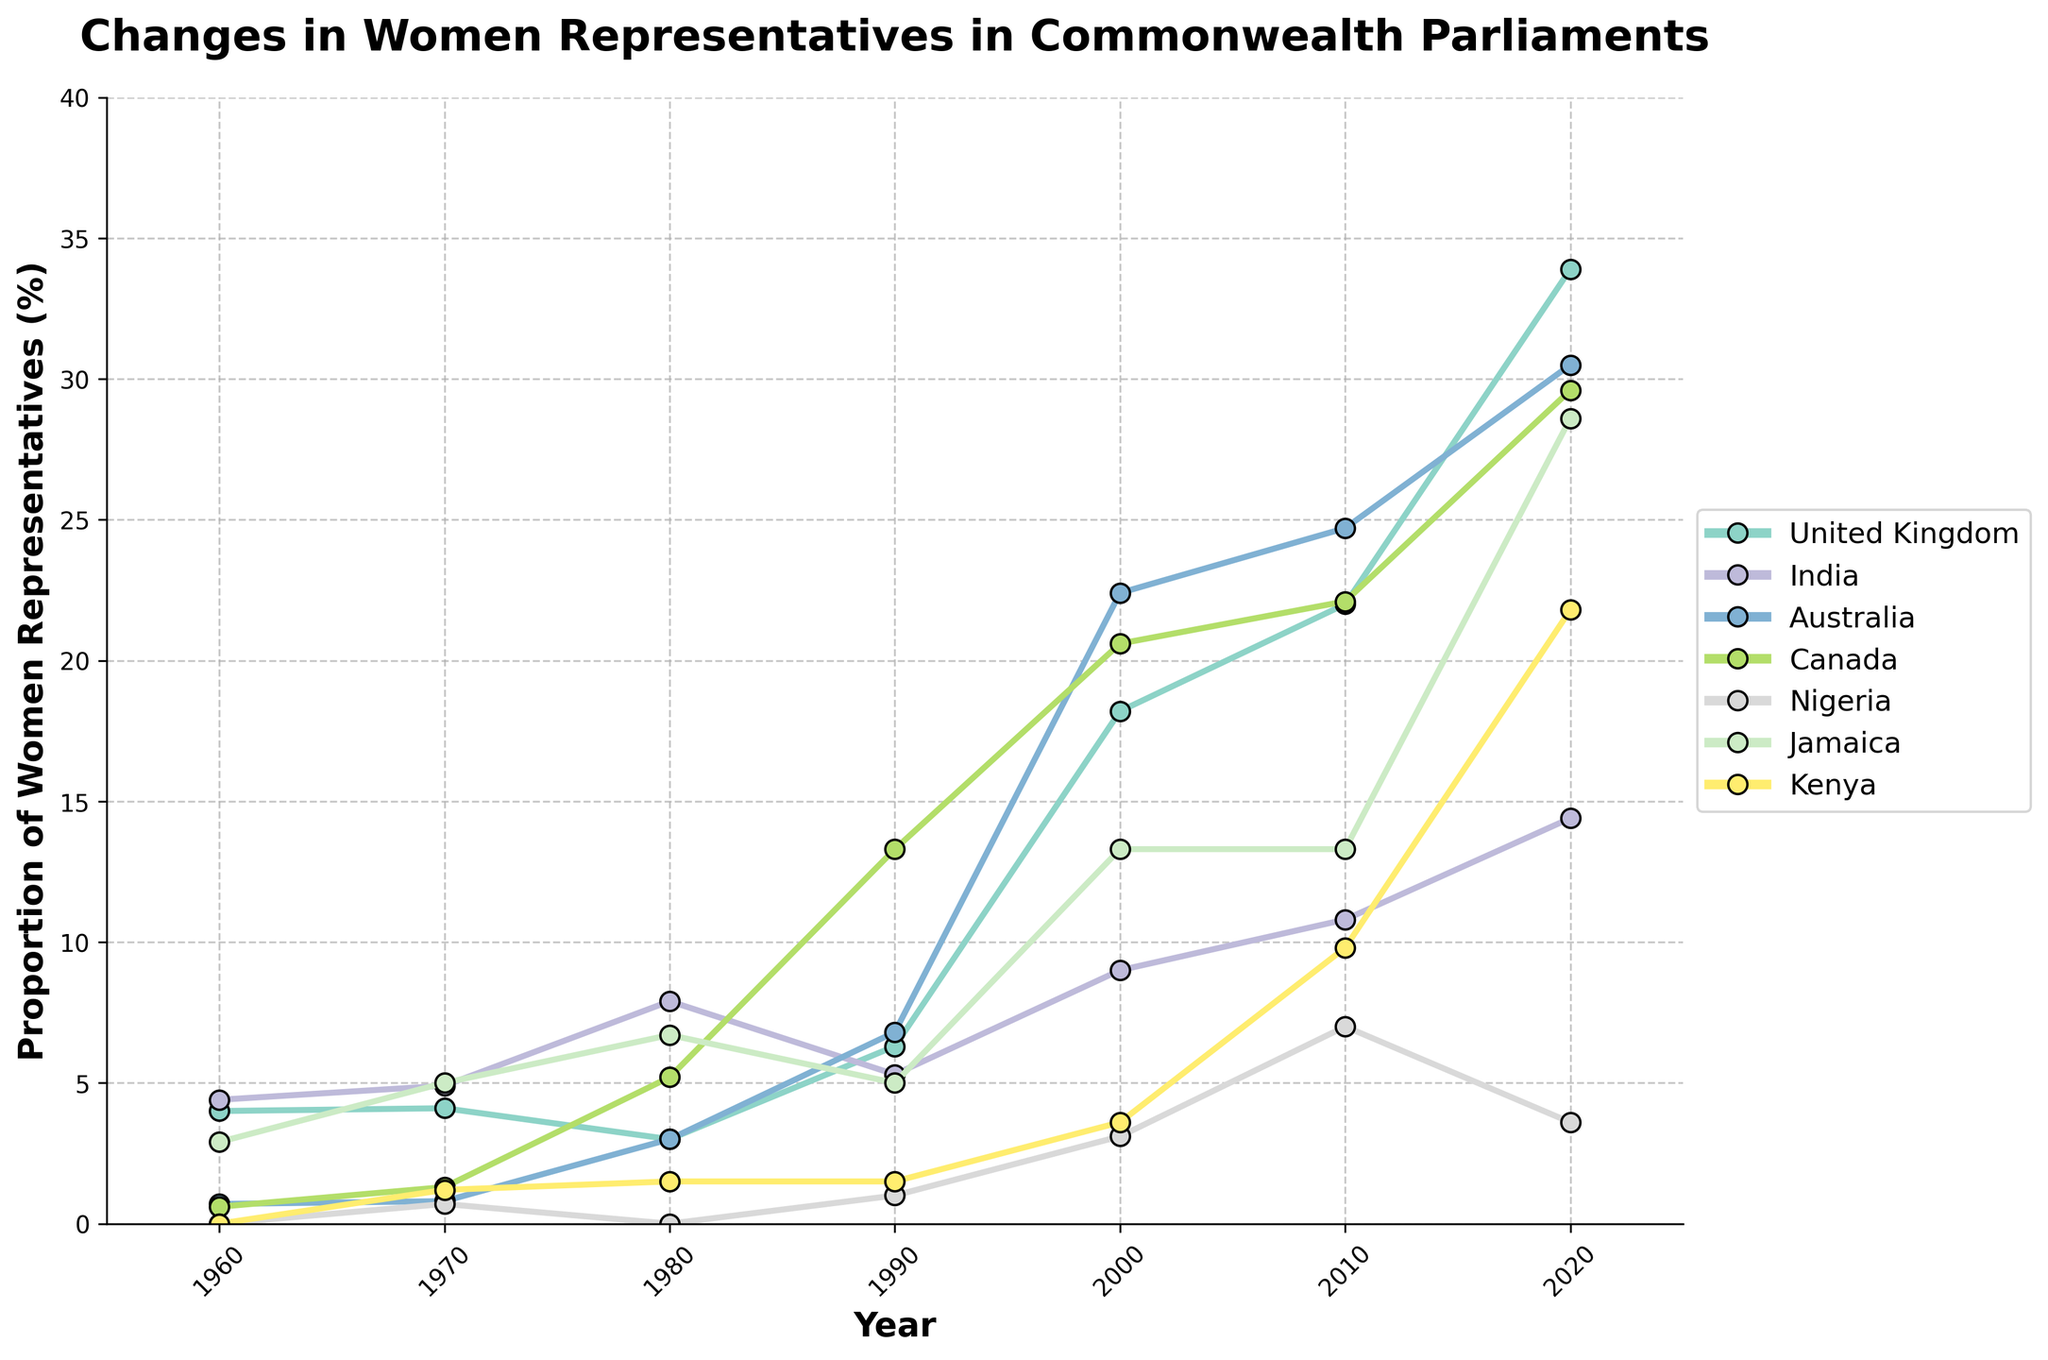Which country showed the highest proportion of women representatives in 2020? Look at the lines corresponding to the year 2020 and identify the highest point. Australia reaches approximately 30.5%, which is higher than all other countries.
Answer: Australia Between which years did the United Kingdom experience the steepest increase in the proportion of women representatives? Analyze the slope of the line for the United Kingdom. The steepest increase appears between 1990 and 2000, increasing from around 6.3% to 18.2%, a jump of approximately 11.9 percentage points.
Answer: 1990 to 2000 How did women's representation change in Kenya from 2010 to 2020, and how does this compare to Nigeria during the same period? From 2010 to 2020, Kenya's representation increased from 9.8% to 21.8%, an increase of 12%. Nigeria's representation increased from 7.0% to 3.6%, a decrease of 3.4%.
Answer: Kenya increased 12%, Nigeria decreased 3.4% Which countries had zero women representatives in 1960? Look at the data points for the year 1960. Nigeria and Kenya both have zero values.
Answer: Nigeria and Kenya Which country has the most fluctuating trend over the entire period? Identify the country with the most changes in the slopes of its line. India and Jamaica show variable trends, but Jamaica's has more ups and downs, making it the most fluctuating.
Answer: Jamaica What was the average proportion of women representatives in Canada from 1970 to 2020? Average the values of Canada from 1970 to 2020: (1.3+5.2+13.3+20.6+22.1+29.6) / 6 = 15.35.
Answer: 15.35% In which year did most countries see an increase in women representatives compared to the previous recorded year? Compare year-over-year changes across all countries. The year 2000 shows an increase in most countries compared to 1990.
Answer: 2000 What is the range of the proportion of women representatives in Jamaica from 1960 to 2020? Subtract the minimum value from the maximum for Jamaica: 28.6% (2020) - 2.9% (1960) = 25.7%.
Answer: 25.7% Compare the rates of increase in women's representation from 1960 to 2020 for Australia and India. For Australia: (30.5% - 0.7%) / 60 years = 0.497% per year. For India: (14.4% - 4.4%) / 60 years = 0.167% per year. Australia's rate is higher.
Answer: Australia: 0.497% per year, India: 0.167% per year If current trends continue, which country is likely to surpass 35% women representatives by 2030? Extend the line trends visually. The United Kingdom is closest to 35% in 2020 at 33.9% and is likely to surpass it by 2030 if current trends continue.
Answer: United Kingdom 